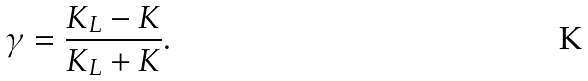Convert formula to latex. <formula><loc_0><loc_0><loc_500><loc_500>\gamma = \frac { K _ { L } - K } { K _ { L } + K } .</formula> 